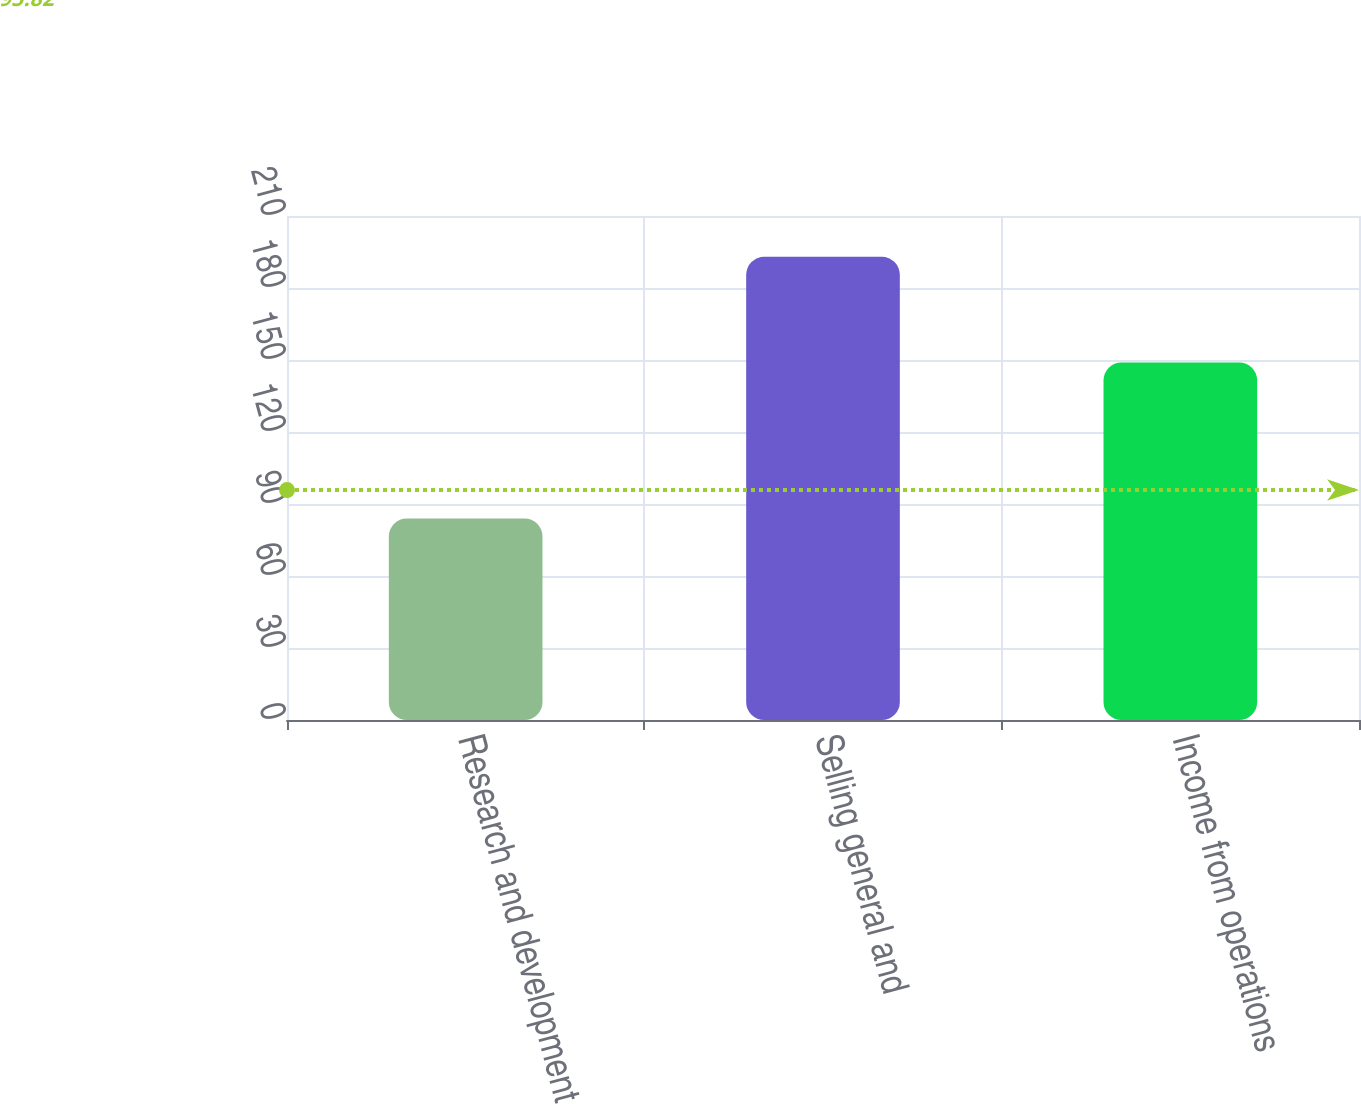<chart> <loc_0><loc_0><loc_500><loc_500><bar_chart><fcel>Research and development<fcel>Selling general and<fcel>Income from operations<nl><fcel>84<fcel>193<fcel>149<nl></chart> 